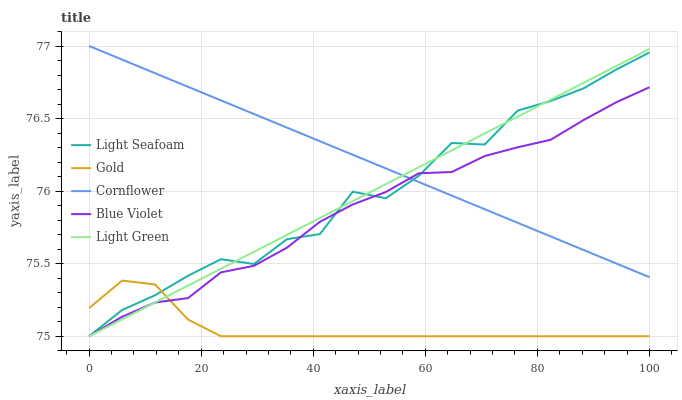Does Gold have the minimum area under the curve?
Answer yes or no. Yes. Does Cornflower have the maximum area under the curve?
Answer yes or no. Yes. Does Light Seafoam have the minimum area under the curve?
Answer yes or no. No. Does Light Seafoam have the maximum area under the curve?
Answer yes or no. No. Is Cornflower the smoothest?
Answer yes or no. Yes. Is Light Seafoam the roughest?
Answer yes or no. Yes. Is Light Seafoam the smoothest?
Answer yes or no. No. Is Cornflower the roughest?
Answer yes or no. No. Does Light Green have the lowest value?
Answer yes or no. Yes. Does Cornflower have the lowest value?
Answer yes or no. No. Does Cornflower have the highest value?
Answer yes or no. Yes. Does Light Seafoam have the highest value?
Answer yes or no. No. Is Gold less than Cornflower?
Answer yes or no. Yes. Is Cornflower greater than Gold?
Answer yes or no. Yes. Does Light Green intersect Light Seafoam?
Answer yes or no. Yes. Is Light Green less than Light Seafoam?
Answer yes or no. No. Is Light Green greater than Light Seafoam?
Answer yes or no. No. Does Gold intersect Cornflower?
Answer yes or no. No. 